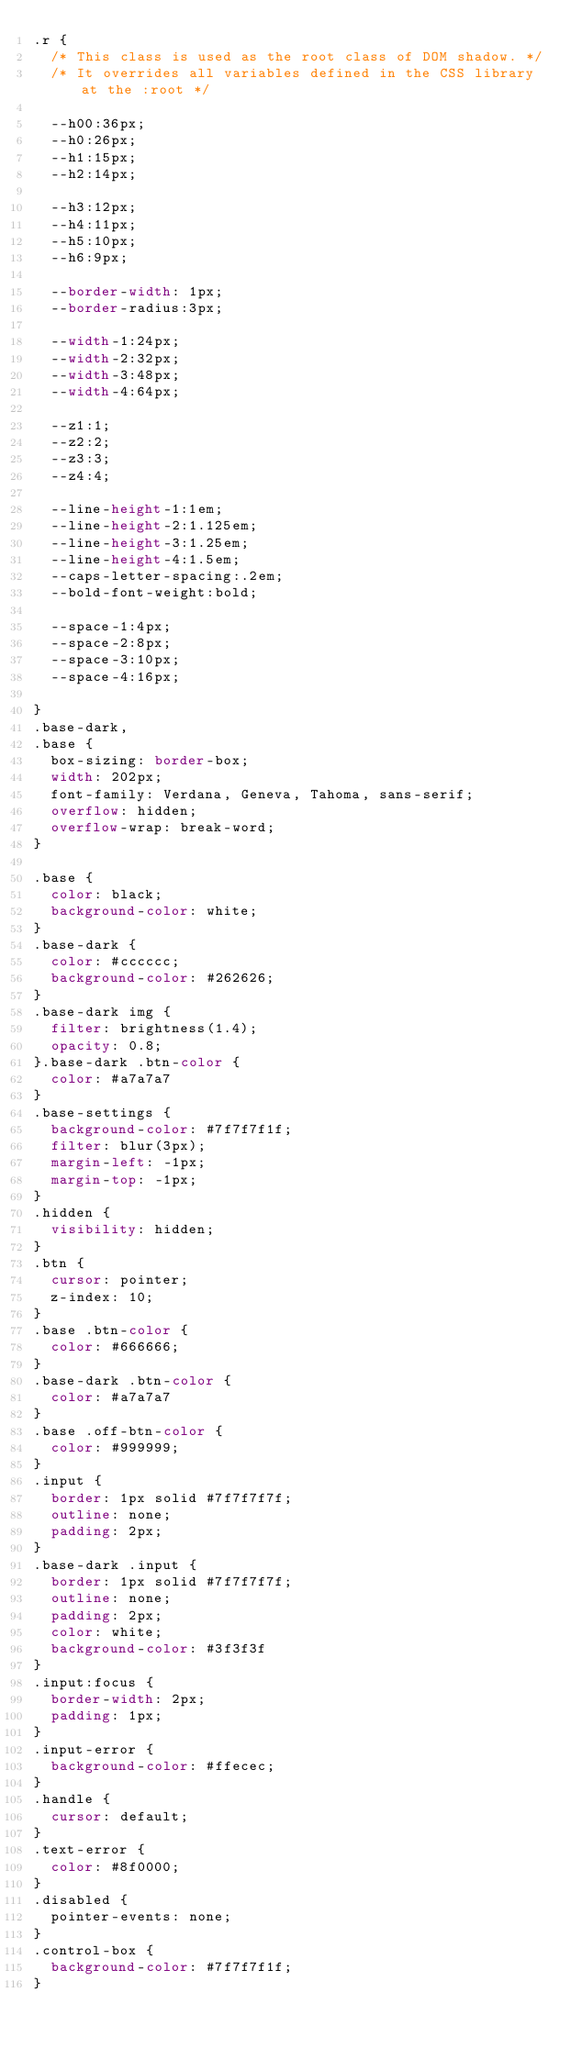Convert code to text. <code><loc_0><loc_0><loc_500><loc_500><_CSS_>.r {
  /* This class is used as the root class of DOM shadow. */
  /* It overrides all variables defined in the CSS library at the :root */

  --h00:36px;
  --h0:26px;
  --h1:15px;
  --h2:14px;

  --h3:12px;
  --h4:11px;
  --h5:10px;
  --h6:9px;

  --border-width: 1px;
  --border-radius:3px;

  --width-1:24px;
  --width-2:32px;
  --width-3:48px;
  --width-4:64px;

  --z1:1;
  --z2:2;
  --z3:3;
  --z4:4;

  --line-height-1:1em;
  --line-height-2:1.125em;
  --line-height-3:1.25em;
  --line-height-4:1.5em;
  --caps-letter-spacing:.2em;
  --bold-font-weight:bold;

  --space-1:4px;
  --space-2:8px;
  --space-3:10px;
  --space-4:16px;

}
.base-dark,
.base {
  box-sizing: border-box;
  width: 202px;
  font-family: Verdana, Geneva, Tahoma, sans-serif;
  overflow: hidden;
  overflow-wrap: break-word;
}

.base {
  color: black;
  background-color: white;
}
.base-dark {
  color: #cccccc;
  background-color: #262626;
}
.base-dark img {
  filter: brightness(1.4);
  opacity: 0.8;
}.base-dark .btn-color {
  color: #a7a7a7
}
.base-settings {
  background-color: #7f7f7f1f;
  filter: blur(3px);
  margin-left: -1px;
  margin-top: -1px;
}
.hidden {
  visibility: hidden;
}
.btn {
  cursor: pointer;
  z-index: 10;
}
.base .btn-color {
  color: #666666;
}
.base-dark .btn-color {
  color: #a7a7a7
}
.base .off-btn-color {
  color: #999999;
}
.input {
  border: 1px solid #7f7f7f7f;
  outline: none;
  padding: 2px;
}
.base-dark .input {
  border: 1px solid #7f7f7f7f;
  outline: none;
  padding: 2px;
  color: white;
  background-color: #3f3f3f
}
.input:focus {
  border-width: 2px;
  padding: 1px;
}
.input-error {
  background-color: #ffecec;
}
.handle {
  cursor: default;
}
.text-error {
  color: #8f0000;
}
.disabled {
  pointer-events: none;
}
.control-box {
  background-color: #7f7f7f1f;
}
</code> 